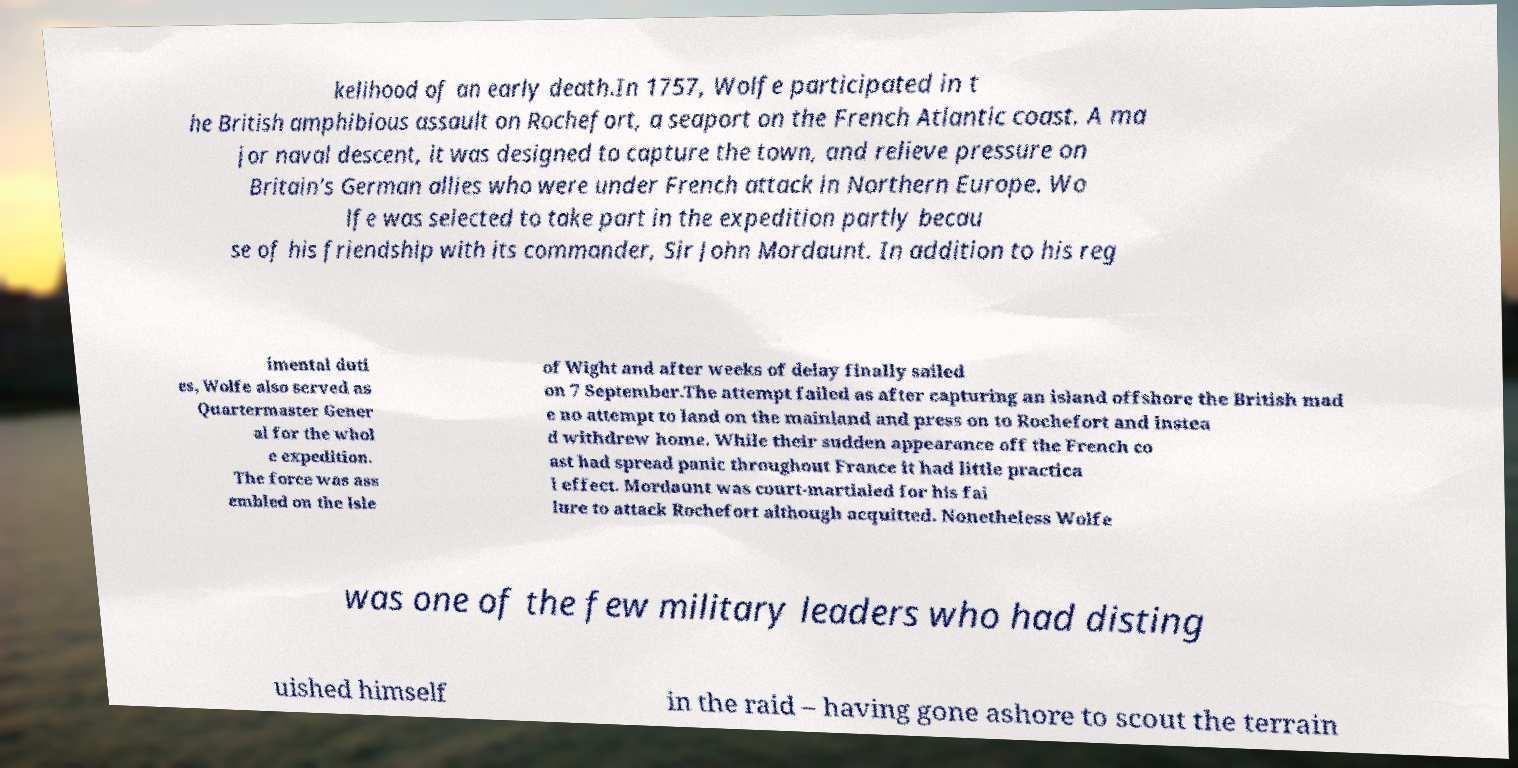Could you assist in decoding the text presented in this image and type it out clearly? kelihood of an early death.In 1757, Wolfe participated in t he British amphibious assault on Rochefort, a seaport on the French Atlantic coast. A ma jor naval descent, it was designed to capture the town, and relieve pressure on Britain's German allies who were under French attack in Northern Europe. Wo lfe was selected to take part in the expedition partly becau se of his friendship with its commander, Sir John Mordaunt. In addition to his reg imental duti es, Wolfe also served as Quartermaster Gener al for the whol e expedition. The force was ass embled on the Isle of Wight and after weeks of delay finally sailed on 7 September.The attempt failed as after capturing an island offshore the British mad e no attempt to land on the mainland and press on to Rochefort and instea d withdrew home. While their sudden appearance off the French co ast had spread panic throughout France it had little practica l effect. Mordaunt was court-martialed for his fai lure to attack Rochefort although acquitted. Nonetheless Wolfe was one of the few military leaders who had disting uished himself in the raid – having gone ashore to scout the terrain 